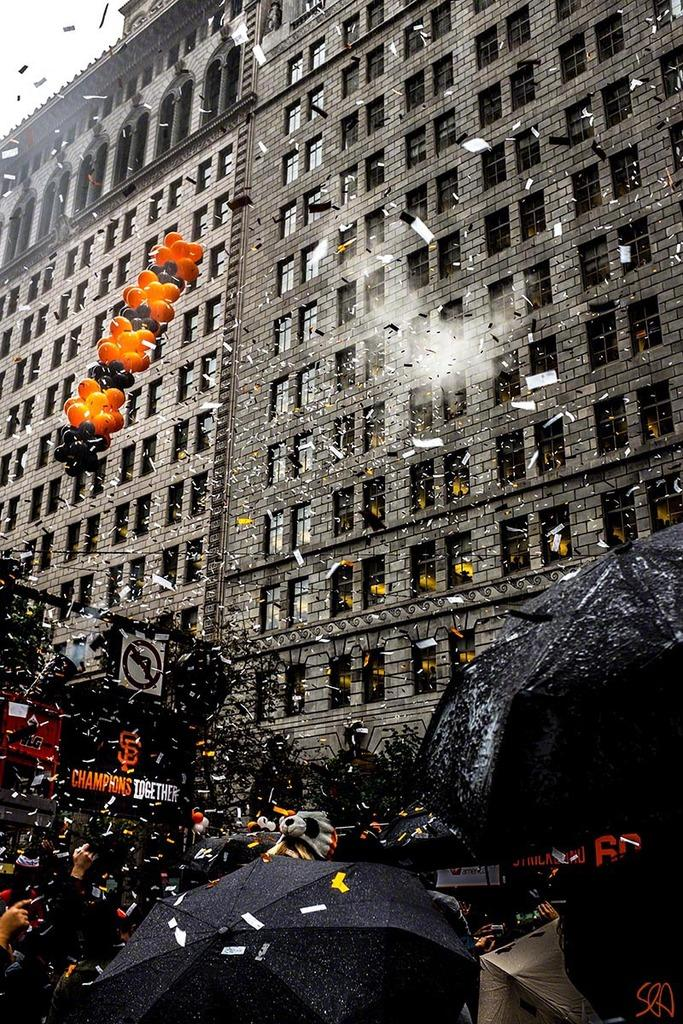What type of structure is present in the image? There is a high-rise building in the image. What decorations or accessories can be seen in the image? There are balloons in the image. What objects are related to writing or documentation in the image? There are papers in the image. Who is present in the image, and what are they doing? There are people standing at the bottom of the image, and they are enjoying a party. What type of debt can be seen in the image? There is no debt visible in the image. What time of day is it in the image, considering the presence of a crow? There is no crow present in the image, so it cannot be used to determine the time of day. 